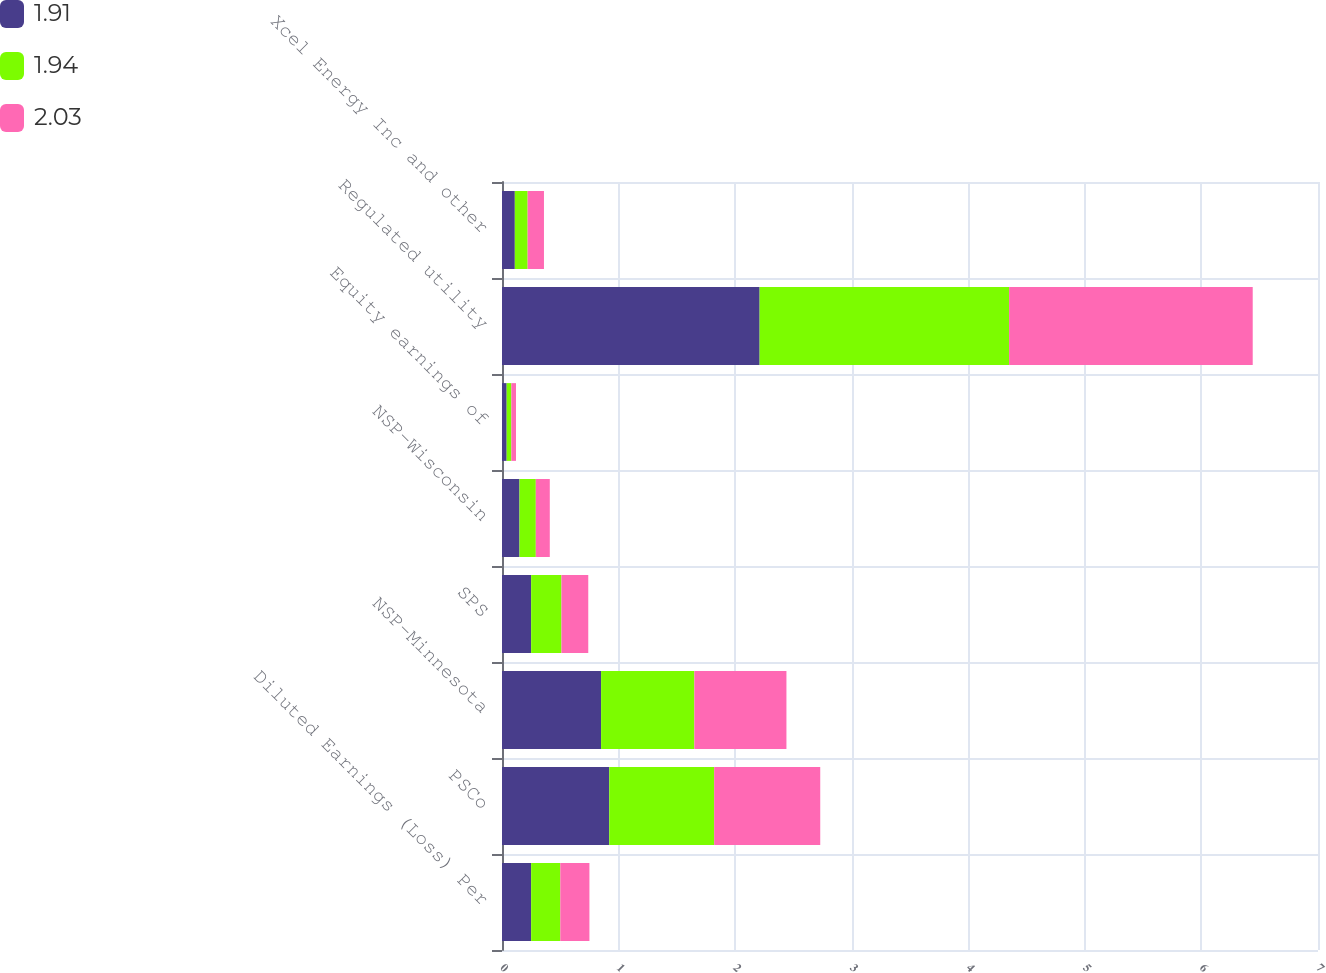Convert chart to OTSL. <chart><loc_0><loc_0><loc_500><loc_500><stacked_bar_chart><ecel><fcel>Diluted Earnings (Loss) Per<fcel>PSCo<fcel>NSP-Minnesota<fcel>SPS<fcel>NSP-Wisconsin<fcel>Equity earnings of<fcel>Regulated utility<fcel>Xcel Energy Inc and other<nl><fcel>1.91<fcel>0.25<fcel>0.92<fcel>0.85<fcel>0.25<fcel>0.15<fcel>0.04<fcel>2.21<fcel>0.11<nl><fcel>1.94<fcel>0.25<fcel>0.9<fcel>0.8<fcel>0.26<fcel>0.14<fcel>0.04<fcel>2.14<fcel>0.11<nl><fcel>2.03<fcel>0.25<fcel>0.91<fcel>0.79<fcel>0.23<fcel>0.12<fcel>0.04<fcel>2.09<fcel>0.14<nl></chart> 